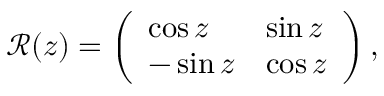<formula> <loc_0><loc_0><loc_500><loc_500>\mathcal { R } ( z ) = \left ( \begin{array} { l l } { \cos z } & { \sin z } \\ { - \sin z } & { \cos z } \end{array} \right ) ,</formula> 